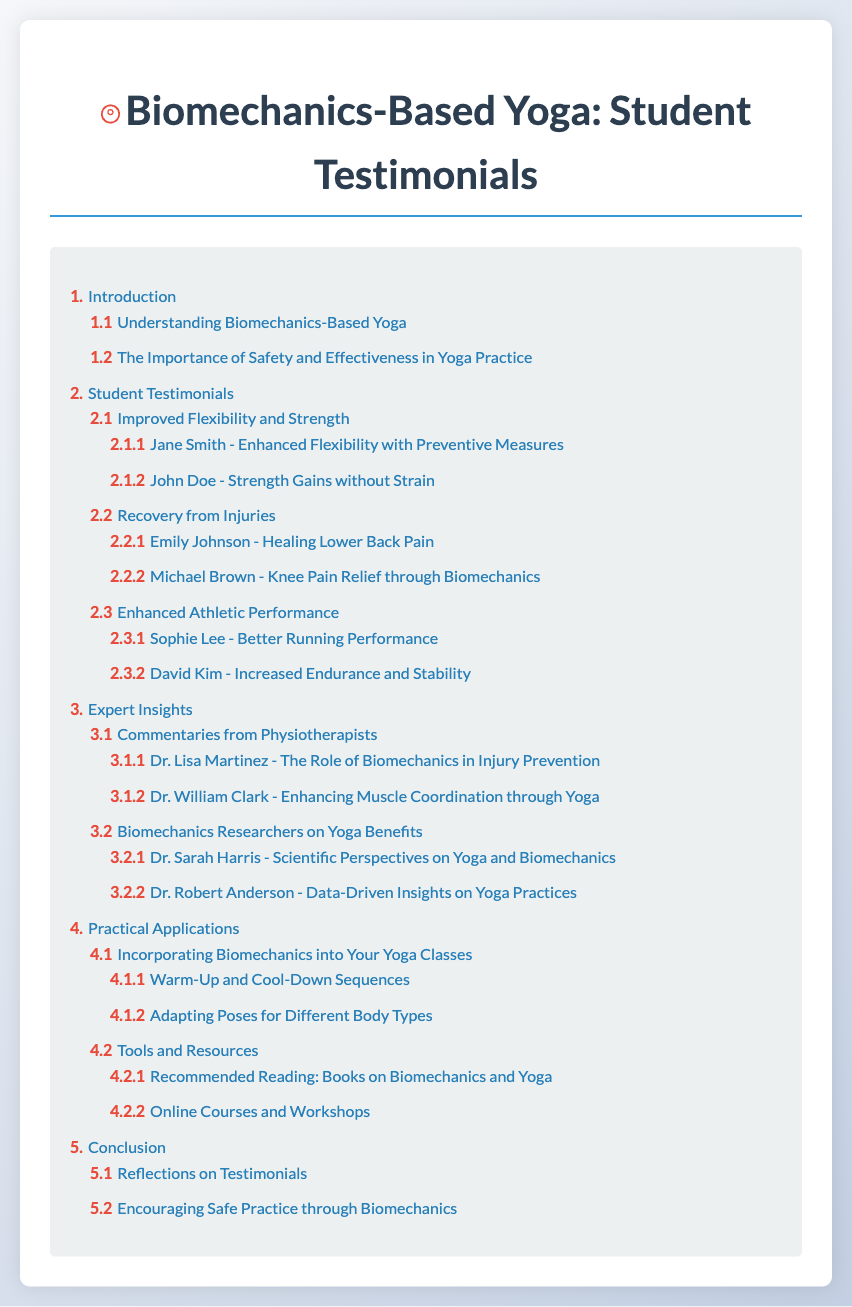What is the main title of the document? The main title is displayed prominently at the top of the document, which is "Biomechanics-Based Yoga: Student Testimonials."
Answer: Biomechanics-Based Yoga: Student Testimonials How many main sections are in the Table of Contents? The Table of Contents lists five main sections (numbered 1 to 5).
Answer: 5 Who is the student that experienced enhanced flexibility with preventive measures? The student's name is mentioned under the section about improved flexibility and strength, specifically focusing on preventive measures.
Answer: Jane Smith What aspect of yoga does section 1.2 focus on? Section 1.2 addresses a critical element in yoga practice that ensures safety and effectiveness during sessions.
Answer: The Importance of Safety and Effectiveness in Yoga Practice Which expert discusses the role of biomechanics in injury prevention? An expert's commentary is outlined in section 3.1.1, focusing on biomechanics' impact on preventing injuries in practice.
Answer: Dr. Lisa Martinez What are the two subtopics listed under "Practical Applications"? These subtopics highlight relevant strategies or tools applicable in yoga, which are included in the same section.
Answer: Incorporating Biomechanics into Your Yoga Classes, Tools and Resources How many student testimonials are listed under "Improved Flexibility and Strength"? The section provides specific names and experiences related to flexibility and strength improvements, indicating the number present.
Answer: 2 Which section contains insights from researchers on yoga benefits? The subsection discusses expert opinions regarding the advantages of yoga as informed by research on biomechanics.
Answer: Biomechanics Researchers on Yoga Benefits What is the last main section of the document? The title indicates the culmination of the document’s arguments and insights before concluding thoughts and reflections.
Answer: Conclusion 